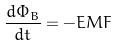<formula> <loc_0><loc_0><loc_500><loc_500>\frac { d \Phi _ { B } } { d t } = - E M F</formula> 